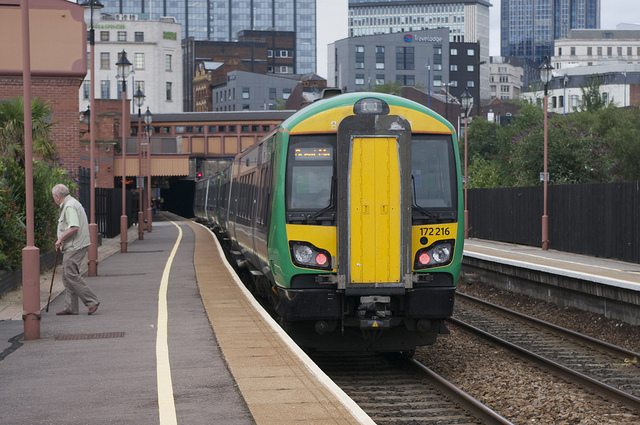Please transcribe the text in this image. 172 216 